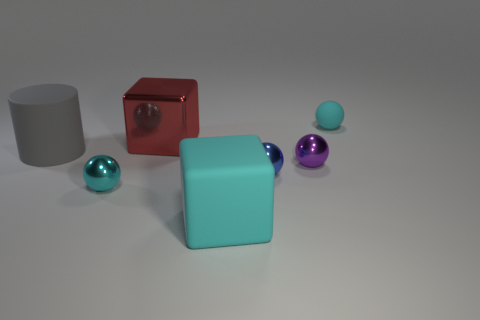Based on their positions, can you describe a possible interaction between the cylinder and the red cube? Certainly. In this static scene, one could imagine the cylinder and red cube as sentient characters in a narrative. The large grey cylinder stands upright, calm and stoic, while the red cube, tipped at an angle, appears dynamic and playful. Perhaps the red cube is telling the cylinder about an exciting adventure it's about to embark on or has just returned from. 